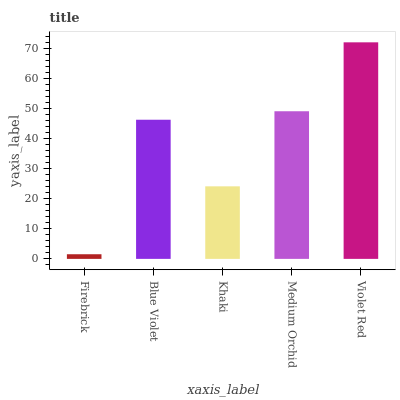Is Firebrick the minimum?
Answer yes or no. Yes. Is Violet Red the maximum?
Answer yes or no. Yes. Is Blue Violet the minimum?
Answer yes or no. No. Is Blue Violet the maximum?
Answer yes or no. No. Is Blue Violet greater than Firebrick?
Answer yes or no. Yes. Is Firebrick less than Blue Violet?
Answer yes or no. Yes. Is Firebrick greater than Blue Violet?
Answer yes or no. No. Is Blue Violet less than Firebrick?
Answer yes or no. No. Is Blue Violet the high median?
Answer yes or no. Yes. Is Blue Violet the low median?
Answer yes or no. Yes. Is Medium Orchid the high median?
Answer yes or no. No. Is Firebrick the low median?
Answer yes or no. No. 